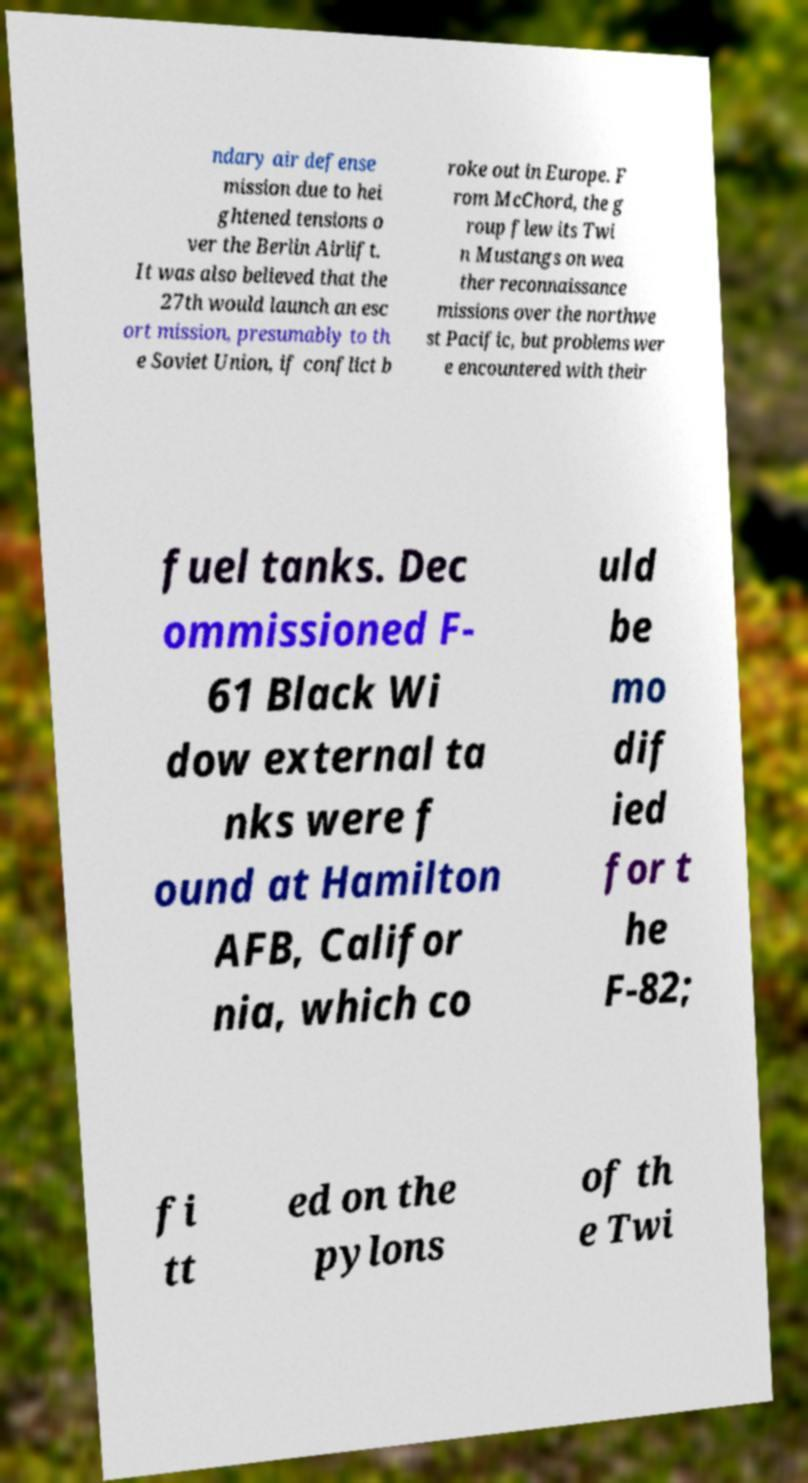Please read and relay the text visible in this image. What does it say? ndary air defense mission due to hei ghtened tensions o ver the Berlin Airlift. It was also believed that the 27th would launch an esc ort mission, presumably to th e Soviet Union, if conflict b roke out in Europe. F rom McChord, the g roup flew its Twi n Mustangs on wea ther reconnaissance missions over the northwe st Pacific, but problems wer e encountered with their fuel tanks. Dec ommissioned F- 61 Black Wi dow external ta nks were f ound at Hamilton AFB, Califor nia, which co uld be mo dif ied for t he F-82; fi tt ed on the pylons of th e Twi 